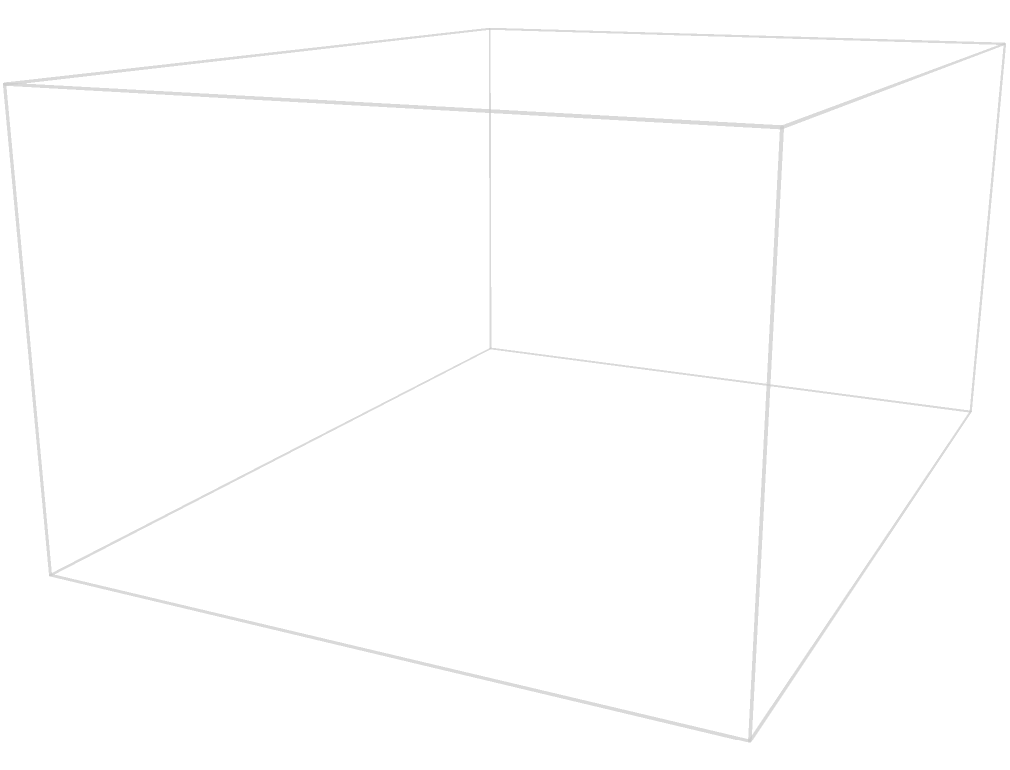As a restaurant owner offering special discounts to moviegoers, you want to optimize your ice cream serving process. You have a rectangular container that measures 4 units in length, 3 units in width, and 2 units in height. If each scoop of ice cream is a perfect sphere with a diameter of 1.6 units, what is the maximum number of scoops that can fit in a single layer at the bottom of the container without overlapping? To solve this problem, we need to follow these steps:

1. Determine the dimensions of the container:
   Length (L) = 4 units
   Width (W) = 3 units
   Height (H) = 2 units

2. Calculate the diameter of each ice cream scoop:
   Diameter = 1.6 units
   Radius (r) = 1.6 / 2 = 0.8 units

3. Calculate the number of scoops that can fit along the length:
   Number along length = floor(L / (2r)) = floor(4 / 1.6) = floor(2.5) = 2

4. Calculate the number of scoops that can fit along the width:
   Number along width = floor(W / (2r)) = floor(3 / 1.6) = floor(1.875) = 1

5. Calculate the total number of scoops in a single layer:
   Total scoops = (Number along length) × (Number along width)
   Total scoops = 2 × 1 = 2

Therefore, the maximum number of scoops that can fit in a single layer at the bottom of the container without overlapping is 2.

Note: The height of the container (2 units) is sufficient to accommodate the height of a single layer of scoops (1.6 units), so it doesn't affect the calculation for a single layer.
Answer: 2 scoops 